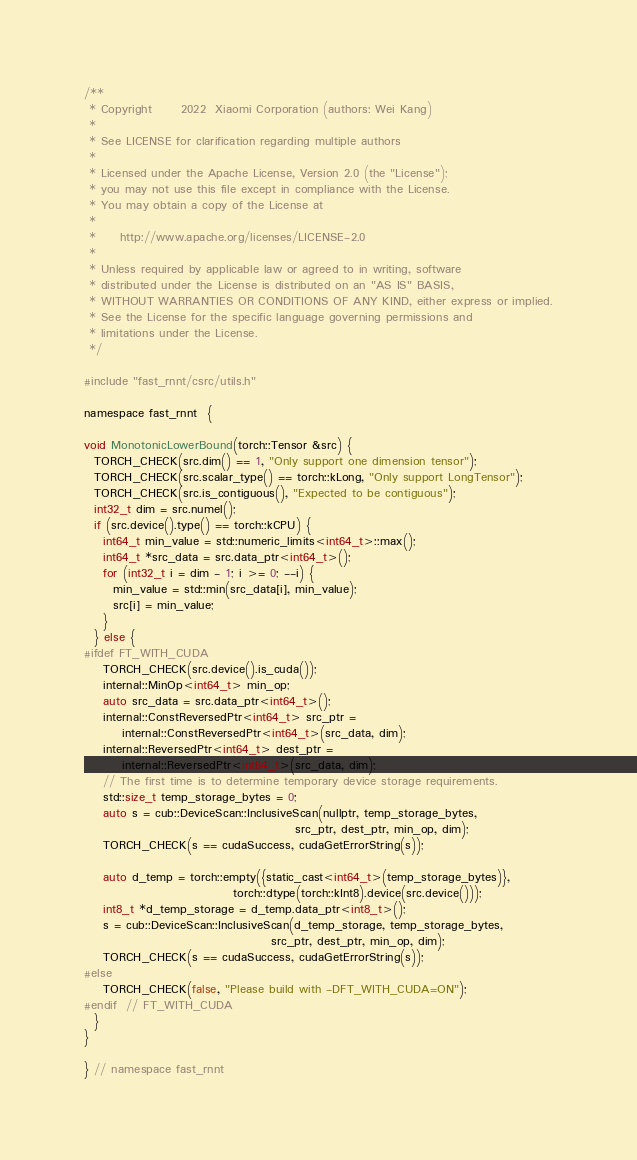<code> <loc_0><loc_0><loc_500><loc_500><_Cuda_>/**
 * Copyright      2022  Xiaomi Corporation (authors: Wei Kang)
 *
 * See LICENSE for clarification regarding multiple authors
 *
 * Licensed under the Apache License, Version 2.0 (the "License");
 * you may not use this file except in compliance with the License.
 * You may obtain a copy of the License at
 *
 *     http://www.apache.org/licenses/LICENSE-2.0
 *
 * Unless required by applicable law or agreed to in writing, software
 * distributed under the License is distributed on an "AS IS" BASIS,
 * WITHOUT WARRANTIES OR CONDITIONS OF ANY KIND, either express or implied.
 * See the License for the specific language governing permissions and
 * limitations under the License.
 */

#include "fast_rnnt/csrc/utils.h"

namespace fast_rnnt  {

void MonotonicLowerBound(torch::Tensor &src) {
  TORCH_CHECK(src.dim() == 1, "Only support one dimension tensor");
  TORCH_CHECK(src.scalar_type() == torch::kLong, "Only support LongTensor");
  TORCH_CHECK(src.is_contiguous(), "Expected to be contiguous");
  int32_t dim = src.numel();
  if (src.device().type() == torch::kCPU) {
    int64_t min_value = std::numeric_limits<int64_t>::max();
    int64_t *src_data = src.data_ptr<int64_t>();
    for (int32_t i = dim - 1; i >= 0; --i) {
      min_value = std::min(src_data[i], min_value);
      src[i] = min_value;
    }
  } else {
#ifdef FT_WITH_CUDA
    TORCH_CHECK(src.device().is_cuda());
    internal::MinOp<int64_t> min_op;
    auto src_data = src.data_ptr<int64_t>();
    internal::ConstReversedPtr<int64_t> src_ptr =
        internal::ConstReversedPtr<int64_t>(src_data, dim);
    internal::ReversedPtr<int64_t> dest_ptr =
        internal::ReversedPtr<int64_t>(src_data, dim);
    // The first time is to determine temporary device storage requirements.
    std::size_t temp_storage_bytes = 0;
    auto s = cub::DeviceScan::InclusiveScan(nullptr, temp_storage_bytes,
                                            src_ptr, dest_ptr, min_op, dim);
    TORCH_CHECK(s == cudaSuccess, cudaGetErrorString(s));

    auto d_temp = torch::empty({static_cast<int64_t>(temp_storage_bytes)},
                               torch::dtype(torch::kInt8).device(src.device()));
    int8_t *d_temp_storage = d_temp.data_ptr<int8_t>();
    s = cub::DeviceScan::InclusiveScan(d_temp_storage, temp_storage_bytes,
                                       src_ptr, dest_ptr, min_op, dim);
    TORCH_CHECK(s == cudaSuccess, cudaGetErrorString(s));
#else
    TORCH_CHECK(false, "Please build with -DFT_WITH_CUDA=ON");
#endif  // FT_WITH_CUDA
  }
}

} // namespace fast_rnnt

</code> 